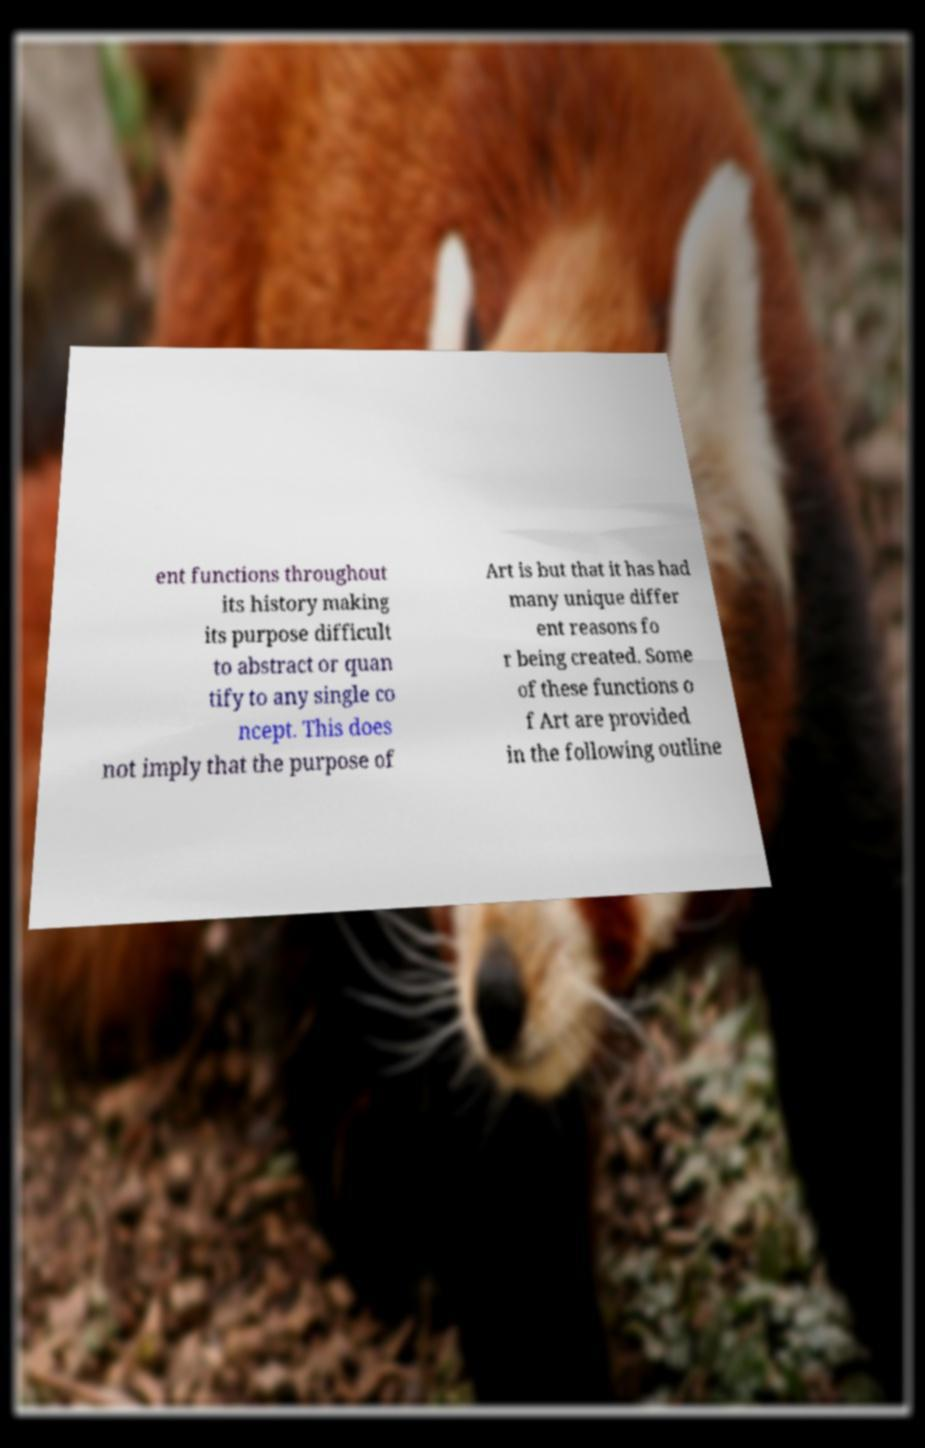Can you accurately transcribe the text from the provided image for me? ent functions throughout its history making its purpose difficult to abstract or quan tify to any single co ncept. This does not imply that the purpose of Art is but that it has had many unique differ ent reasons fo r being created. Some of these functions o f Art are provided in the following outline 